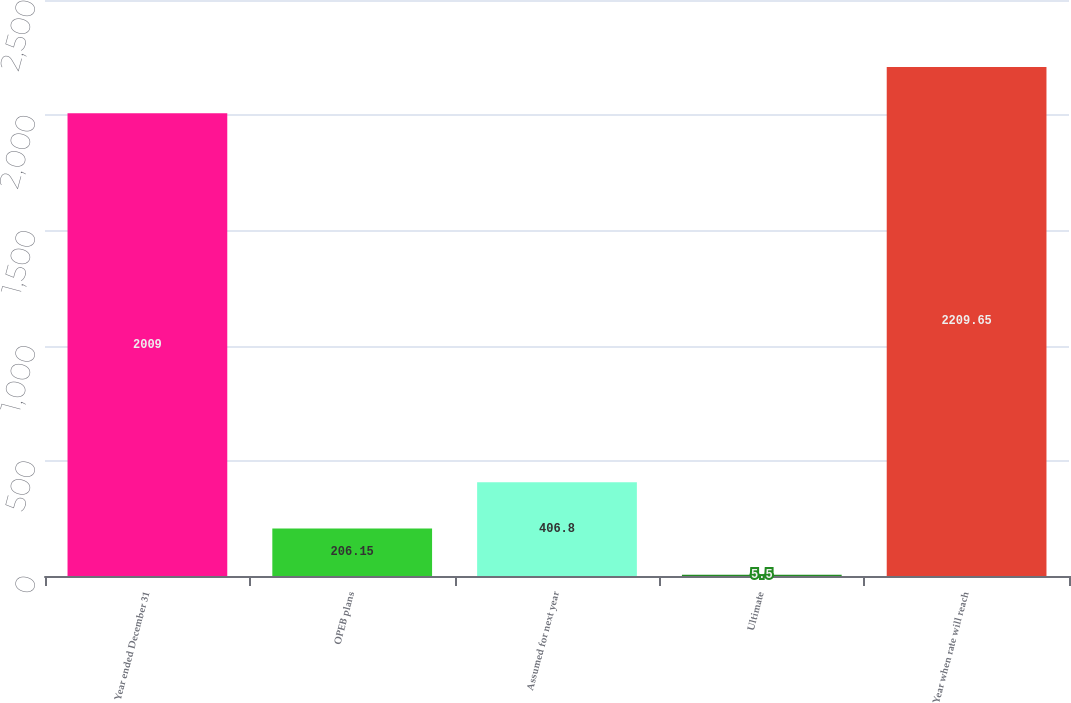Convert chart to OTSL. <chart><loc_0><loc_0><loc_500><loc_500><bar_chart><fcel>Year ended December 31<fcel>OPEB plans<fcel>Assumed for next year<fcel>Ultimate<fcel>Year when rate will reach<nl><fcel>2009<fcel>206.15<fcel>406.8<fcel>5.5<fcel>2209.65<nl></chart> 